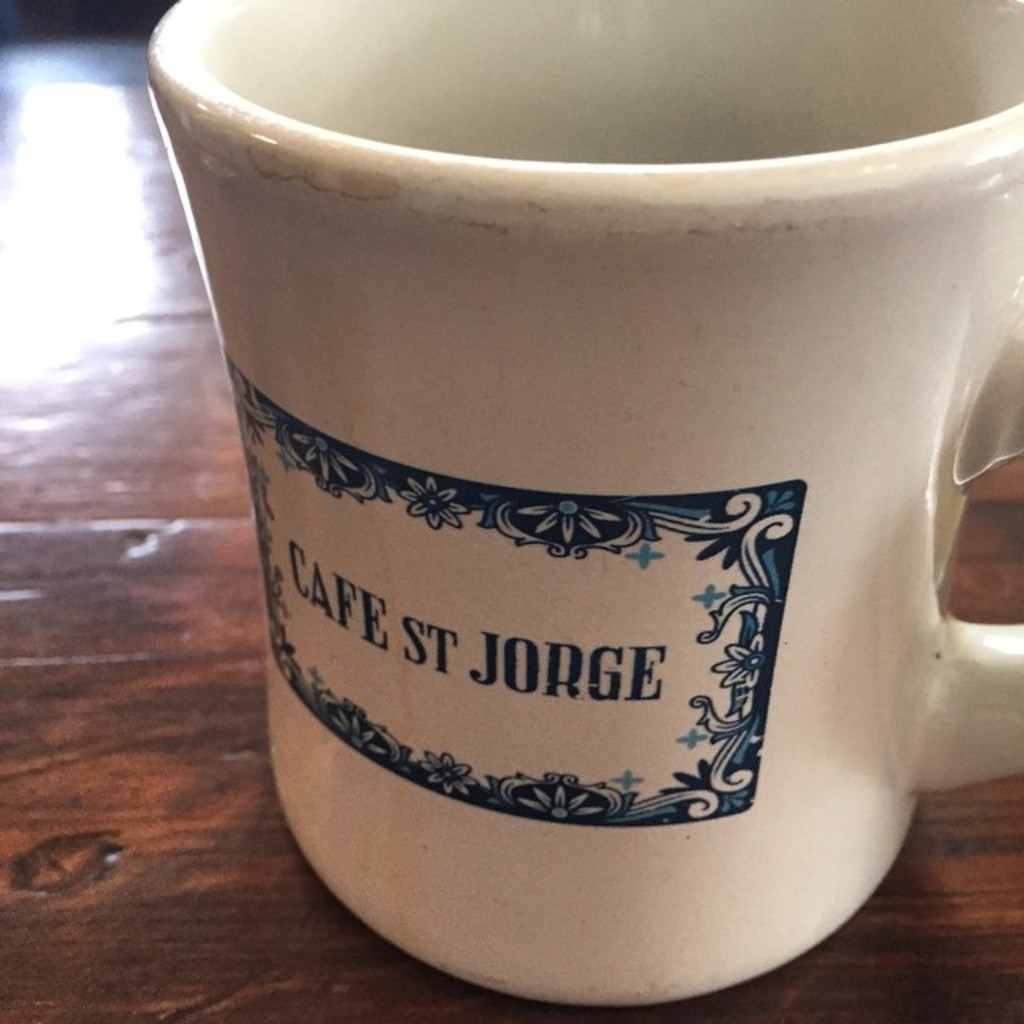What kind of aesthetic does the mug's design convey? The mug's design conveys a quaint and cozy aesthetic, typical of a traditional European cafe. The blue floral ornamentation adds a touch of elegance, making it not only functional but also a decorative piece. Can you imagine the type of setting or location where this mug might be commonly used? This mug would be perfectly at home in a casual, yet stylish cafe setting, perhaps one with wooden tables and a relaxed, welcoming atmosphere. It could also be a favored piece in a kitchen that appreciates country or vintage style decor. 